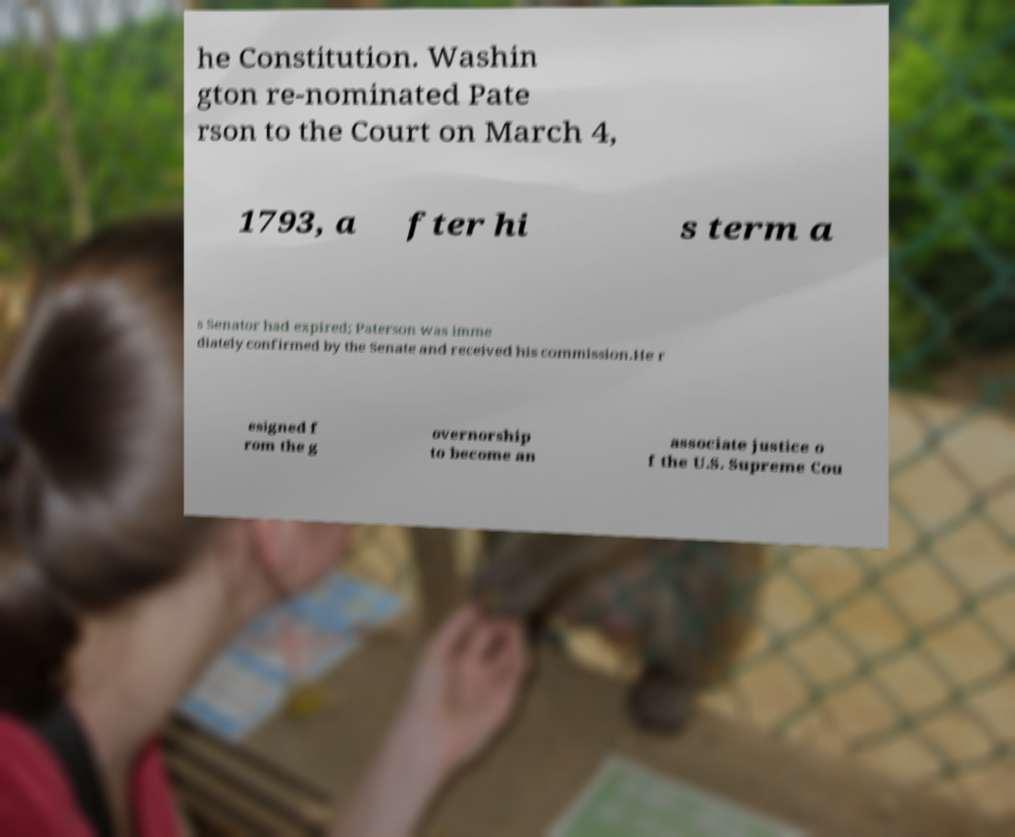Please read and relay the text visible in this image. What does it say? he Constitution. Washin gton re-nominated Pate rson to the Court on March 4, 1793, a fter hi s term a s Senator had expired; Paterson was imme diately confirmed by the Senate and received his commission.He r esigned f rom the g overnorship to become an associate justice o f the U.S. Supreme Cou 